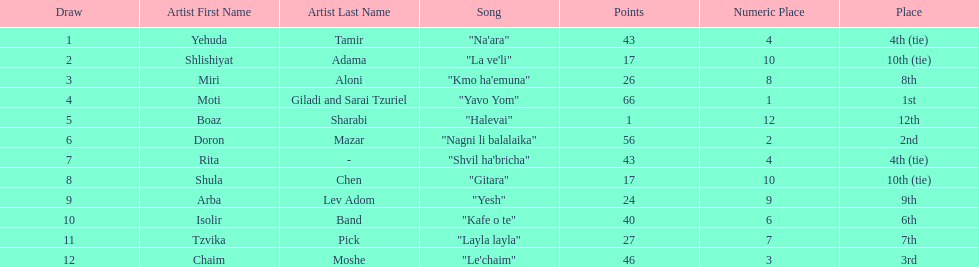What is the name of the song listed before the song "yesh"? "Gitara". 